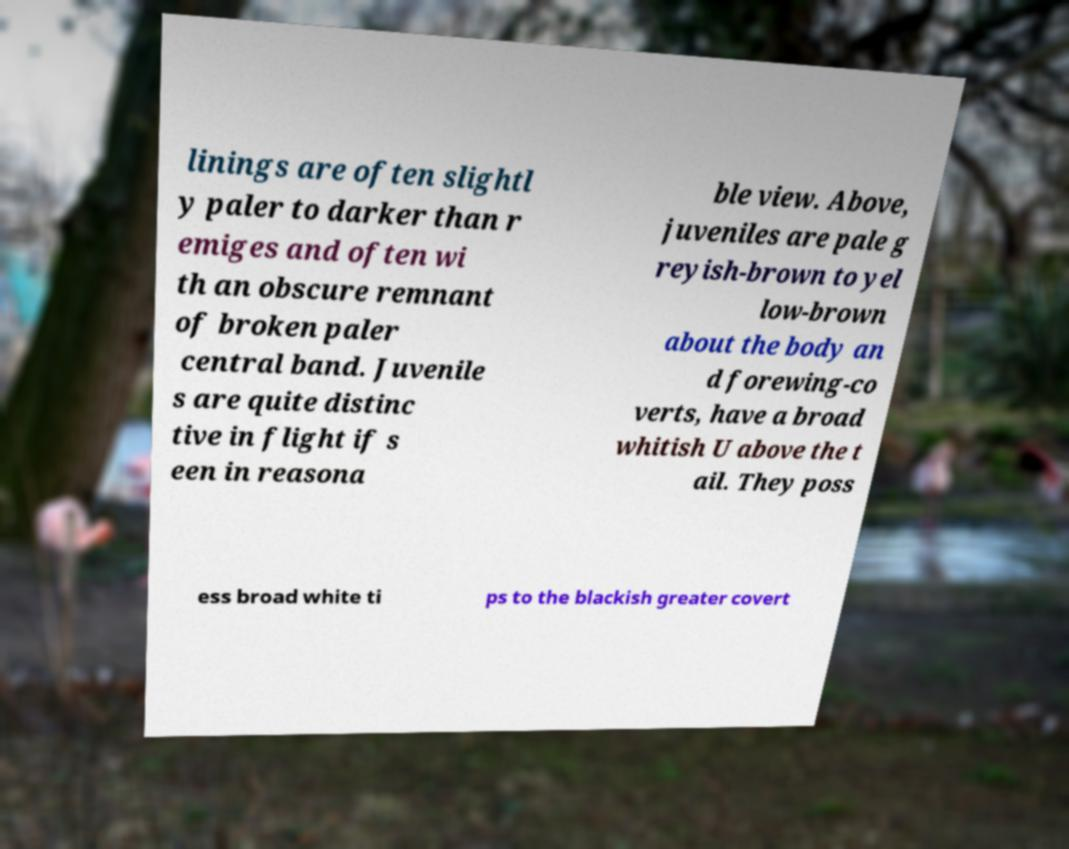Can you read and provide the text displayed in the image?This photo seems to have some interesting text. Can you extract and type it out for me? linings are often slightl y paler to darker than r emiges and often wi th an obscure remnant of broken paler central band. Juvenile s are quite distinc tive in flight if s een in reasona ble view. Above, juveniles are pale g reyish-brown to yel low-brown about the body an d forewing-co verts, have a broad whitish U above the t ail. They poss ess broad white ti ps to the blackish greater covert 